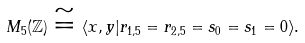<formula> <loc_0><loc_0><loc_500><loc_500>M _ { 5 } ( \mathbb { Z } ) \cong \langle x , y | r _ { 1 , 5 } = r _ { 2 , 5 } = s _ { 0 } = s _ { 1 } = 0 \rangle .</formula> 